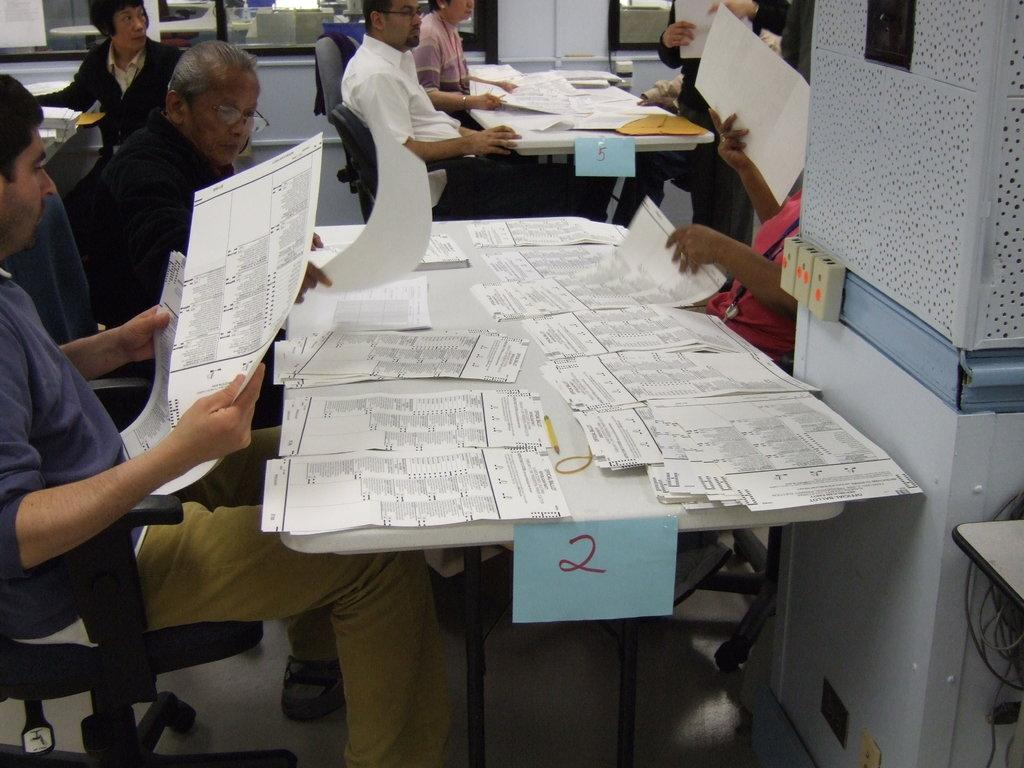What are the people in the image doing? The persons in the image are sitting on chairs. How are the chairs arranged in relation to each other? The chairs are arranged around a table. What is on the table in the image? There are papers on the table. What else can be seen on or around the table? There are additional objects on or around the table. Is the table made of quicksand in the image? No, the table is not made of quicksand; it is a solid surface. What type of knowledge is being shared among the people in the image? The image does not provide information about the type of knowledge being shared among the people. 